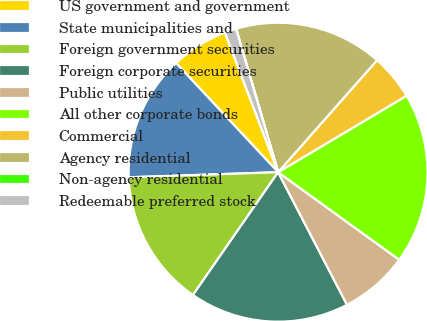<chart> <loc_0><loc_0><loc_500><loc_500><pie_chart><fcel>US government and government<fcel>State municipalities and<fcel>Foreign government securities<fcel>Foreign corporate securities<fcel>Public utilities<fcel>All other corporate bonds<fcel>Commercial<fcel>Agency residential<fcel>Non-agency residential<fcel>Redeemable preferred stock<nl><fcel>6.18%<fcel>13.58%<fcel>14.81%<fcel>17.28%<fcel>7.41%<fcel>18.51%<fcel>4.94%<fcel>16.05%<fcel>0.01%<fcel>1.24%<nl></chart> 